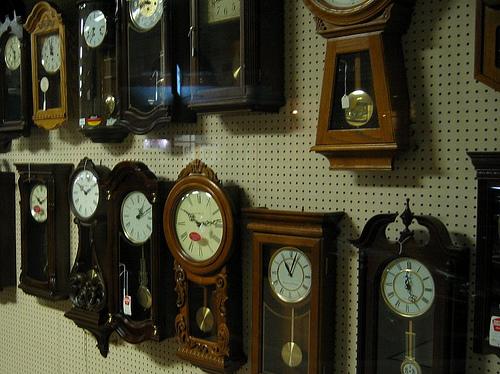Would you like to have a clock like that?
Give a very brief answer. Yes. Are all of these clocks set to the correct time?
Answer briefly. No. How many clocks are there?
Give a very brief answer. 15. Are all clocks showing the same time?
Answer briefly. No. What kind of leaves decorate the top of the center clock?
Concise answer only. None. Is this photo indoors?
Concise answer only. Yes. How many clock faces can be seen?
Give a very brief answer. 12. 